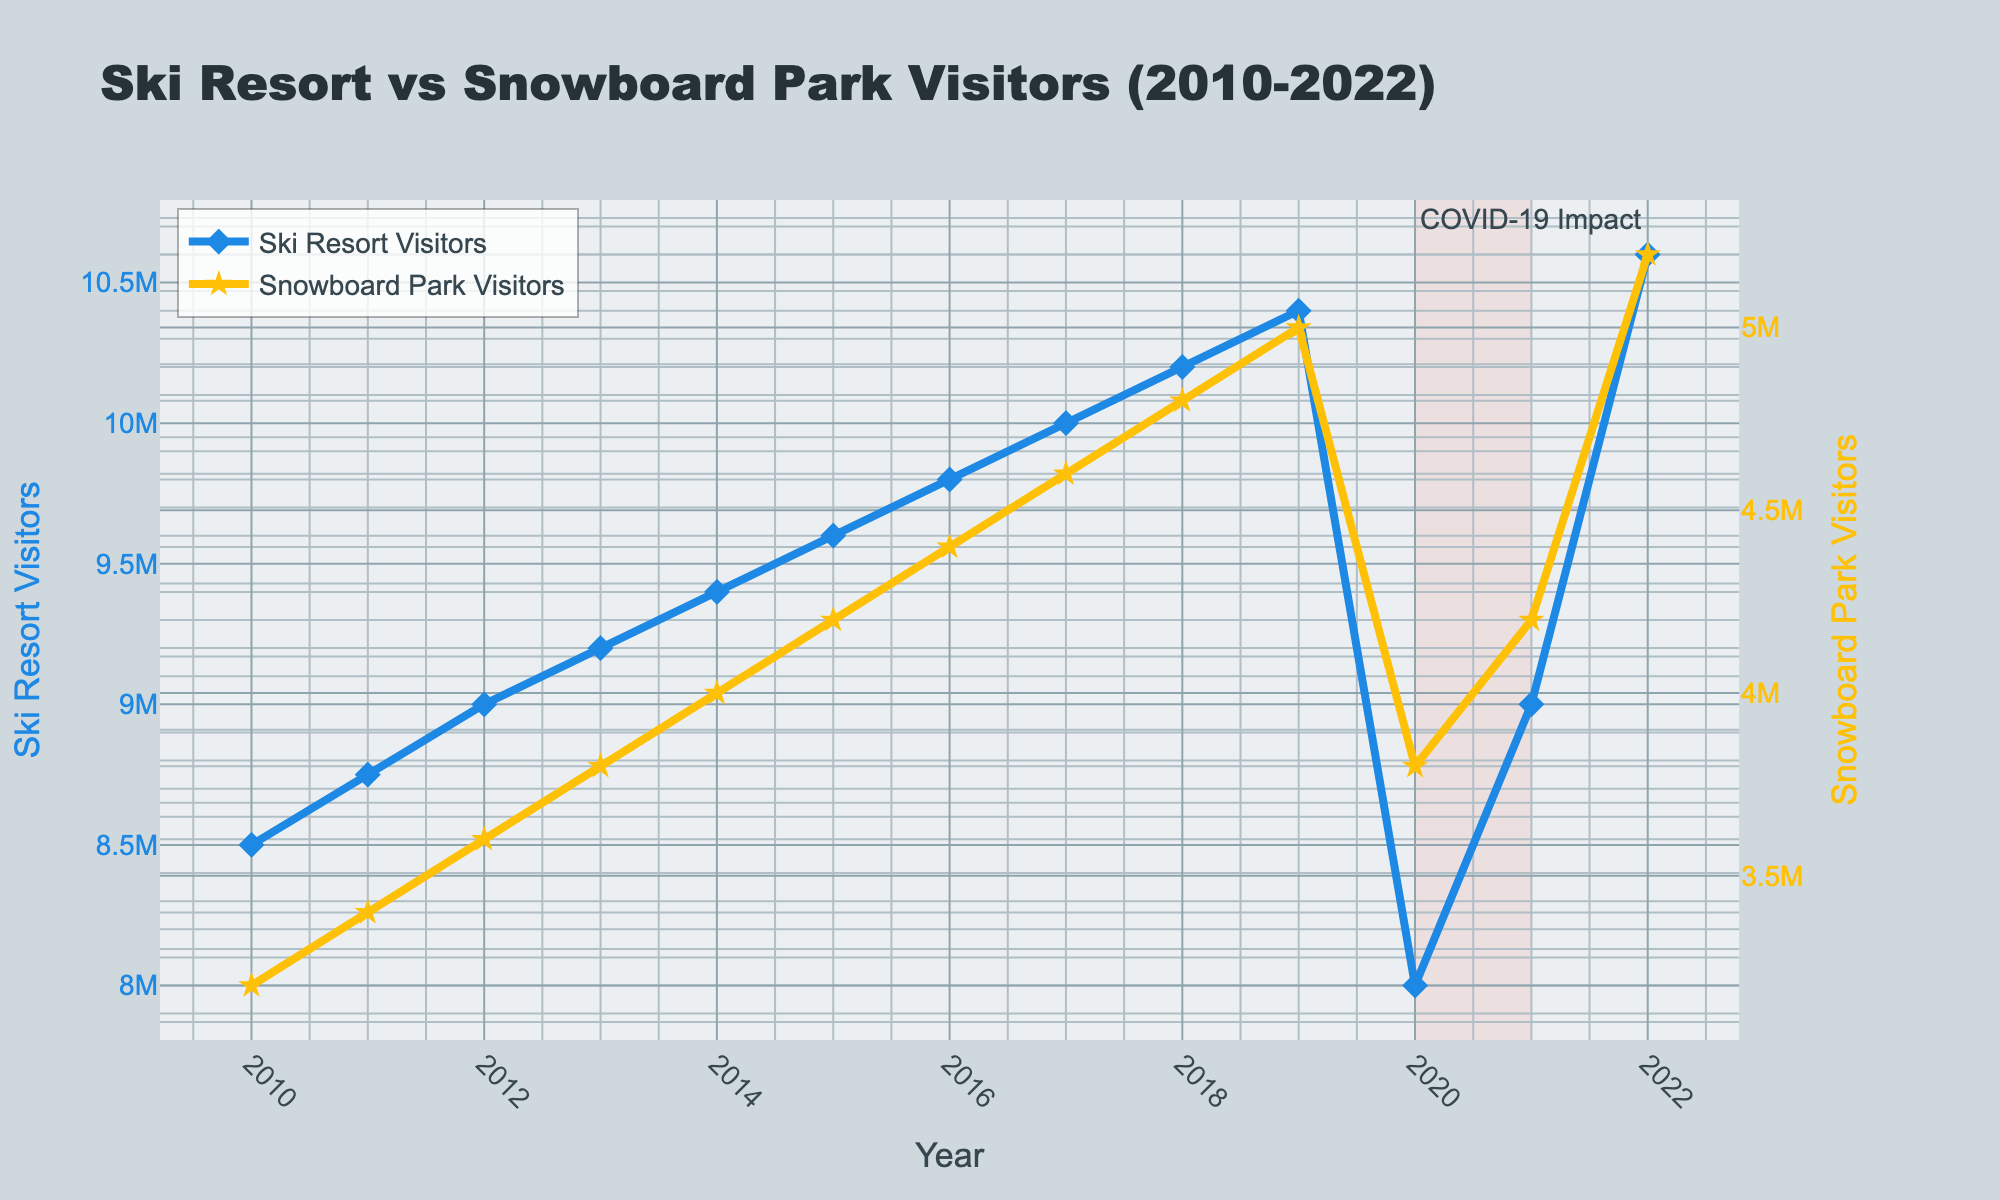what year had the highest number of ski resort visitors? The year with the highest number of ski resort visitors can be identified by looking for the peak in the blue line. The peak occurs in 2022 with 10,600,000 visitors.
Answer: 2022 how did the number of snowboard park visitors change between 2019 and 2020? Compare the 2019 and 2020 data points for snowboard park visitors. In 2019, there were 5,000,000 visitors, while in 2020, there were 3,800,000 visitors. The change is 5,000,000 - 3,800,000 = -1,200,000 visitors.
Answer: -1,200,000 visitors what is the total number of visitors for both ski resorts and snowboard parks in 2015? Add the number of ski resort visitors and snowboard park visitors in 2015. Ski resort: 9,600,000, Snowboard park: 4,200,000. Total = 9,600,000 + 4,200,000 = 13,800,000 visitors.
Answer: 13,800,000 visitors when was the first year that snowboard park visitors exceeded 4,000,000? Check the line representing snowboard park visitors. The first year it exceeds 4,000,000 is 2015.
Answer: 2015 how many visitors did ski resorts gain from 2016 to 2017 compared to snowboard parks? Calculate the difference in visitors for both ski resorts and snowboard parks from 2016 to 2017. Ski resorts: 10,000,000 - 9,800,000 = 200,000 gain. Snowboard parks: 4,600,000 - 4,400,000 = 200,000 gain. Both gain 200,000 visitors each.
Answer: 200,000 each which year had a larger impact in visitor reduction due to COVID-19, 2020 or 2021? Compare the year-over-year reduction in visitors between 2019-2020 and 2020-2021 for both ski resorts and snowboard parks. Ski resorts: 2019-2020: 10,400,000 - 8,000,000 = 2,400,000, Snowboard parks: 5,000,000 - 3,800,000 = 1,200,000. Both reductions are in 2020, indicating 2020 had a larger impact.
Answer: 2020 what is the average number of ski resort visitors from 2010 to 2022? Calculate the average by summing all the ski resort visitors from 2010 to 2022, then dividing by the number of years. (85,00,000 + 87,50,000 + 90,00,000 + 92,00,000 + 94,00,000 + 96,00,000 + 98,00,000 + 10,000,000 + 10,200,000 + 10,400,000 + 8,000,000 + 9,000,000 + 10,600,000) / 13 = 9,60,000
Answer: 9,60,000 